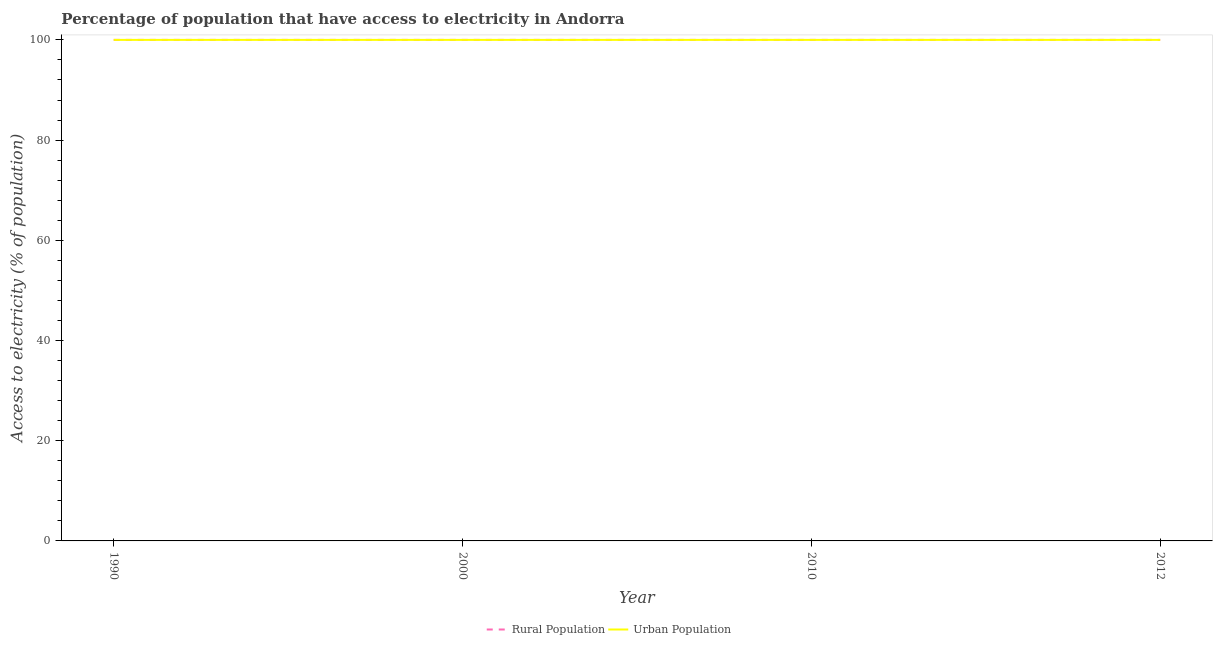How many different coloured lines are there?
Offer a terse response. 2. What is the percentage of rural population having access to electricity in 2010?
Offer a very short reply. 100. Across all years, what is the maximum percentage of rural population having access to electricity?
Make the answer very short. 100. Across all years, what is the minimum percentage of urban population having access to electricity?
Your answer should be very brief. 100. What is the total percentage of rural population having access to electricity in the graph?
Keep it short and to the point. 400. What is the average percentage of urban population having access to electricity per year?
Make the answer very short. 100. In how many years, is the percentage of rural population having access to electricity greater than 80 %?
Keep it short and to the point. 4. What is the difference between the highest and the second highest percentage of urban population having access to electricity?
Your answer should be very brief. 0. What is the difference between the highest and the lowest percentage of urban population having access to electricity?
Ensure brevity in your answer.  0. In how many years, is the percentage of urban population having access to electricity greater than the average percentage of urban population having access to electricity taken over all years?
Offer a terse response. 0. Is the sum of the percentage of rural population having access to electricity in 1990 and 2010 greater than the maximum percentage of urban population having access to electricity across all years?
Your answer should be compact. Yes. Does the percentage of urban population having access to electricity monotonically increase over the years?
Ensure brevity in your answer.  No. Is the percentage of urban population having access to electricity strictly greater than the percentage of rural population having access to electricity over the years?
Your response must be concise. No. Is the percentage of rural population having access to electricity strictly less than the percentage of urban population having access to electricity over the years?
Provide a short and direct response. No. How many lines are there?
Make the answer very short. 2. Are the values on the major ticks of Y-axis written in scientific E-notation?
Offer a very short reply. No. Does the graph contain grids?
Keep it short and to the point. No. Where does the legend appear in the graph?
Give a very brief answer. Bottom center. How are the legend labels stacked?
Offer a terse response. Horizontal. What is the title of the graph?
Give a very brief answer. Percentage of population that have access to electricity in Andorra. Does "Female population" appear as one of the legend labels in the graph?
Provide a short and direct response. No. What is the label or title of the Y-axis?
Ensure brevity in your answer.  Access to electricity (% of population). What is the Access to electricity (% of population) in Urban Population in 1990?
Ensure brevity in your answer.  100. What is the Access to electricity (% of population) in Urban Population in 2000?
Offer a terse response. 100. What is the Access to electricity (% of population) of Rural Population in 2010?
Offer a terse response. 100. What is the Access to electricity (% of population) of Rural Population in 2012?
Keep it short and to the point. 100. What is the Access to electricity (% of population) in Urban Population in 2012?
Your answer should be very brief. 100. Across all years, what is the maximum Access to electricity (% of population) of Rural Population?
Provide a short and direct response. 100. Across all years, what is the minimum Access to electricity (% of population) in Rural Population?
Make the answer very short. 100. What is the total Access to electricity (% of population) in Urban Population in the graph?
Ensure brevity in your answer.  400. What is the difference between the Access to electricity (% of population) in Rural Population in 1990 and that in 2000?
Your answer should be compact. 0. What is the difference between the Access to electricity (% of population) of Urban Population in 1990 and that in 2000?
Your response must be concise. 0. What is the difference between the Access to electricity (% of population) of Urban Population in 1990 and that in 2012?
Provide a succinct answer. 0. What is the difference between the Access to electricity (% of population) of Urban Population in 2000 and that in 2010?
Your answer should be compact. 0. What is the difference between the Access to electricity (% of population) in Urban Population in 2000 and that in 2012?
Keep it short and to the point. 0. What is the difference between the Access to electricity (% of population) in Rural Population in 2010 and that in 2012?
Your answer should be very brief. 0. What is the difference between the Access to electricity (% of population) in Urban Population in 2010 and that in 2012?
Give a very brief answer. 0. What is the difference between the Access to electricity (% of population) of Rural Population in 1990 and the Access to electricity (% of population) of Urban Population in 2012?
Offer a terse response. 0. What is the difference between the Access to electricity (% of population) in Rural Population in 2000 and the Access to electricity (% of population) in Urban Population in 2010?
Provide a short and direct response. 0. What is the average Access to electricity (% of population) in Rural Population per year?
Give a very brief answer. 100. In the year 2000, what is the difference between the Access to electricity (% of population) in Rural Population and Access to electricity (% of population) in Urban Population?
Your response must be concise. 0. In the year 2010, what is the difference between the Access to electricity (% of population) of Rural Population and Access to electricity (% of population) of Urban Population?
Give a very brief answer. 0. What is the ratio of the Access to electricity (% of population) in Rural Population in 1990 to that in 2000?
Provide a short and direct response. 1. What is the ratio of the Access to electricity (% of population) in Urban Population in 1990 to that in 2010?
Your answer should be compact. 1. What is the ratio of the Access to electricity (% of population) of Rural Population in 1990 to that in 2012?
Your answer should be compact. 1. What is the ratio of the Access to electricity (% of population) of Urban Population in 1990 to that in 2012?
Your answer should be very brief. 1. What is the ratio of the Access to electricity (% of population) in Rural Population in 2000 to that in 2010?
Provide a succinct answer. 1. What is the ratio of the Access to electricity (% of population) in Urban Population in 2000 to that in 2010?
Provide a succinct answer. 1. What is the ratio of the Access to electricity (% of population) in Urban Population in 2000 to that in 2012?
Your answer should be compact. 1. What is the ratio of the Access to electricity (% of population) in Rural Population in 2010 to that in 2012?
Your answer should be very brief. 1. What is the difference between the highest and the lowest Access to electricity (% of population) in Rural Population?
Make the answer very short. 0. What is the difference between the highest and the lowest Access to electricity (% of population) in Urban Population?
Give a very brief answer. 0. 